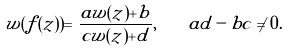Convert formula to latex. <formula><loc_0><loc_0><loc_500><loc_500>w ( f ( z ) ) = \frac { a w ( z ) + b } { c w ( z ) + d } , \quad a d - b c \neq 0 .</formula> 